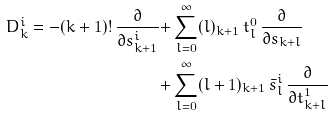Convert formula to latex. <formula><loc_0><loc_0><loc_500><loc_500>D ^ { i } _ { k } = - ( k + 1 ) ! \, \frac { \partial } { \partial s ^ { i } _ { k + 1 } } + & \sum _ { l = 0 } ^ { \infty } ( l ) _ { k + 1 } \, t ^ { 0 } _ { l } \, \frac { \partial } { \partial s _ { k + l } } \\ + & \sum _ { l = 0 } ^ { \infty } ( l + 1 ) _ { k + 1 } \, \bar { s } ^ { i } _ { l } \, \frac { \partial } { \partial t ^ { 1 } _ { k + l } }</formula> 